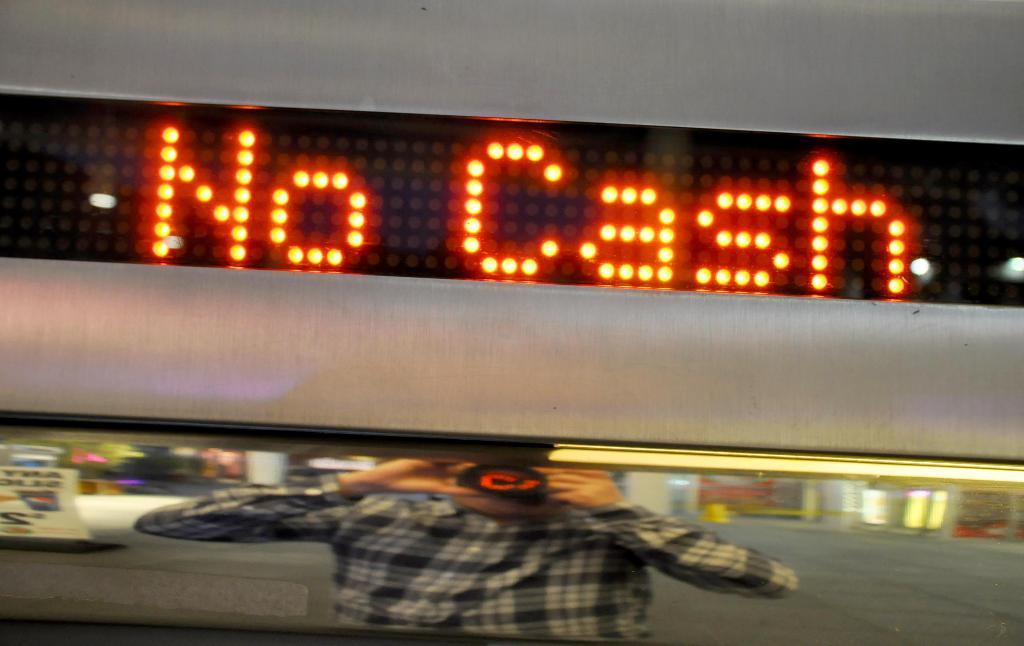Cash or no cash?
Provide a short and direct response. No cash. What are the last two letters of the last word?
Your answer should be compact. Sh. 